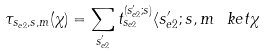<formula> <loc_0><loc_0><loc_500><loc_500>\tau _ { s _ { e 2 } , s , m } ( \chi ) = \sum _ { s _ { e 2 } ^ { \prime } } t ^ { ( s _ { e 2 } ^ { \prime } ; s ) } _ { s _ { e 2 } } \langle s _ { e 2 } ^ { \prime } ; s , m \ k e t { \chi }</formula> 